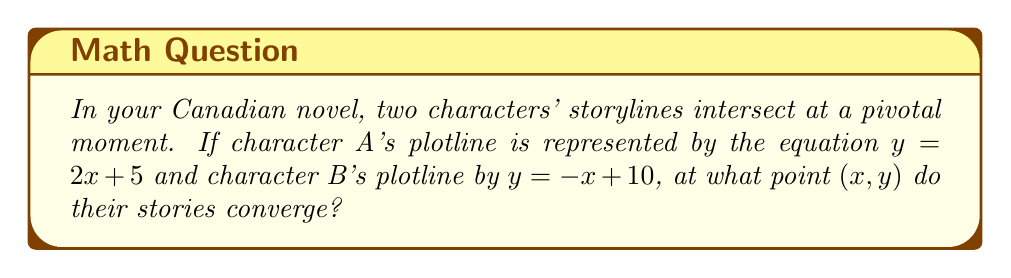Teach me how to tackle this problem. To find the intersection point of these two plotlines, we need to solve the system of equations:

$$\begin{cases}
y = 2x + 5 \\
y = -x + 10
\end{cases}$$

Step 1: Since both equations are equal to y, we can set them equal to each other:
$2x + 5 = -x + 10$

Step 2: Add x to both sides of the equation:
$3x + 5 = 10$

Step 3: Subtract 5 from both sides:
$3x = 5$

Step 4: Divide both sides by 3:
$x = \frac{5}{3}$

Step 5: Now that we know x, we can substitute it into either of the original equations to find y. Let's use the first equation:

$y = 2(\frac{5}{3}) + 5$
$y = \frac{10}{3} + 5$
$y = \frac{10}{3} + \frac{15}{3}$
$y = \frac{25}{3}$

Therefore, the point of intersection is $(\frac{5}{3}, \frac{25}{3})$.
Answer: $(\frac{5}{3}, \frac{25}{3})$ 